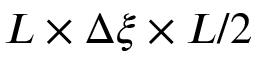<formula> <loc_0><loc_0><loc_500><loc_500>L \times \Delta \xi \times L / 2</formula> 